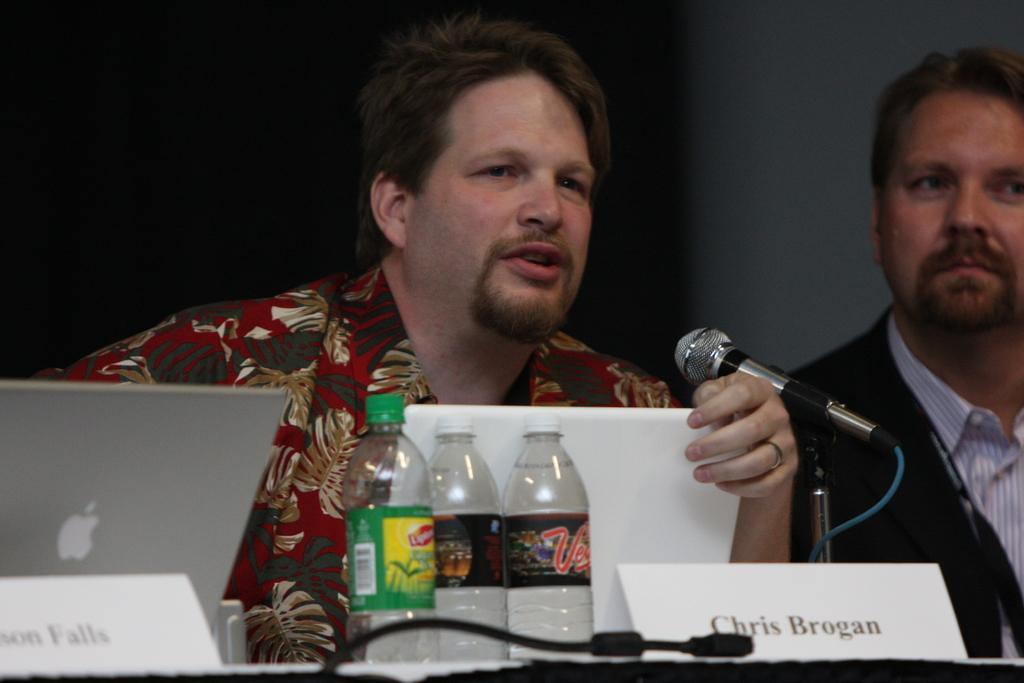Describe this image in one or two sentences. In this image, there is a person in front of the table. This table contains laptop, bottles and mic. There is an another person on the right side of the image wearing clothes. 